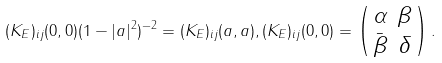<formula> <loc_0><loc_0><loc_500><loc_500>( K _ { E } ) _ { i j } ( 0 , 0 ) ( 1 - | a | ^ { 2 } ) ^ { - 2 } = ( K _ { E } ) _ { i j } ( a , a ) , ( K _ { E } ) _ { i j } ( 0 , 0 ) = \left ( \begin{smallmatrix} \alpha & \beta \\ \bar { \beta } & \delta \end{smallmatrix} \right ) .</formula> 